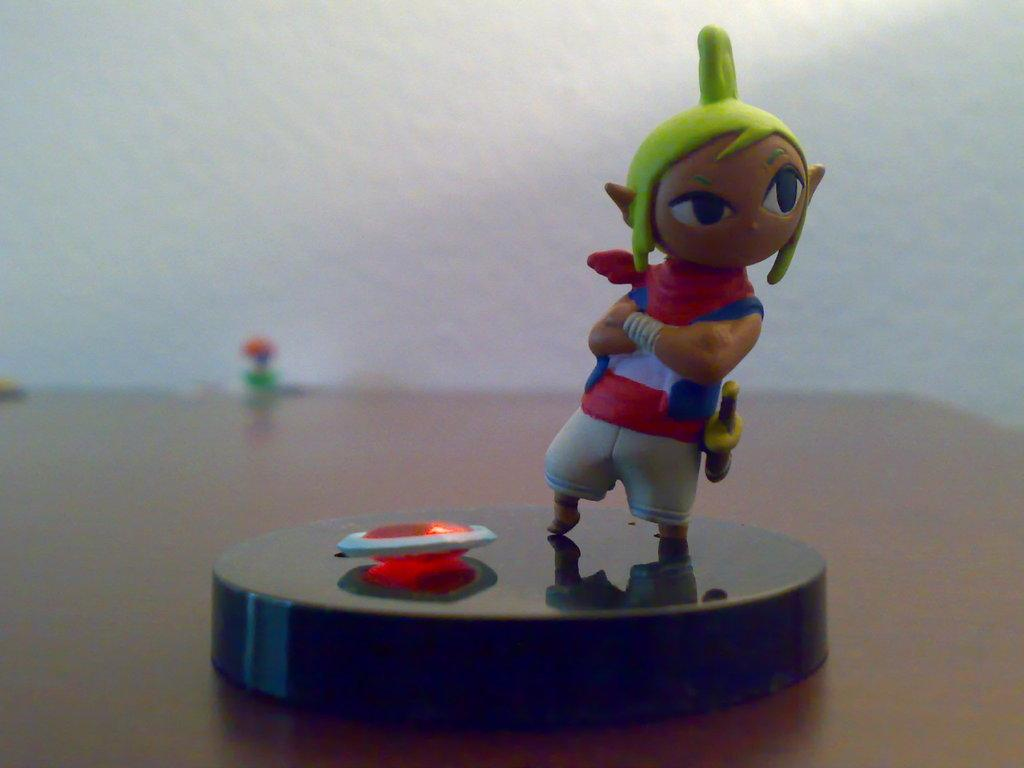What object is placed on the table in the image? There is a toy on the table. What can be seen behind the table in the image? There is a wall visible in the background. What type of glue is being used to attach the unit to the lumber in the image? There is no glue, unit, or lumber present in the image; it only features a toy on a table and a wall in the background. 